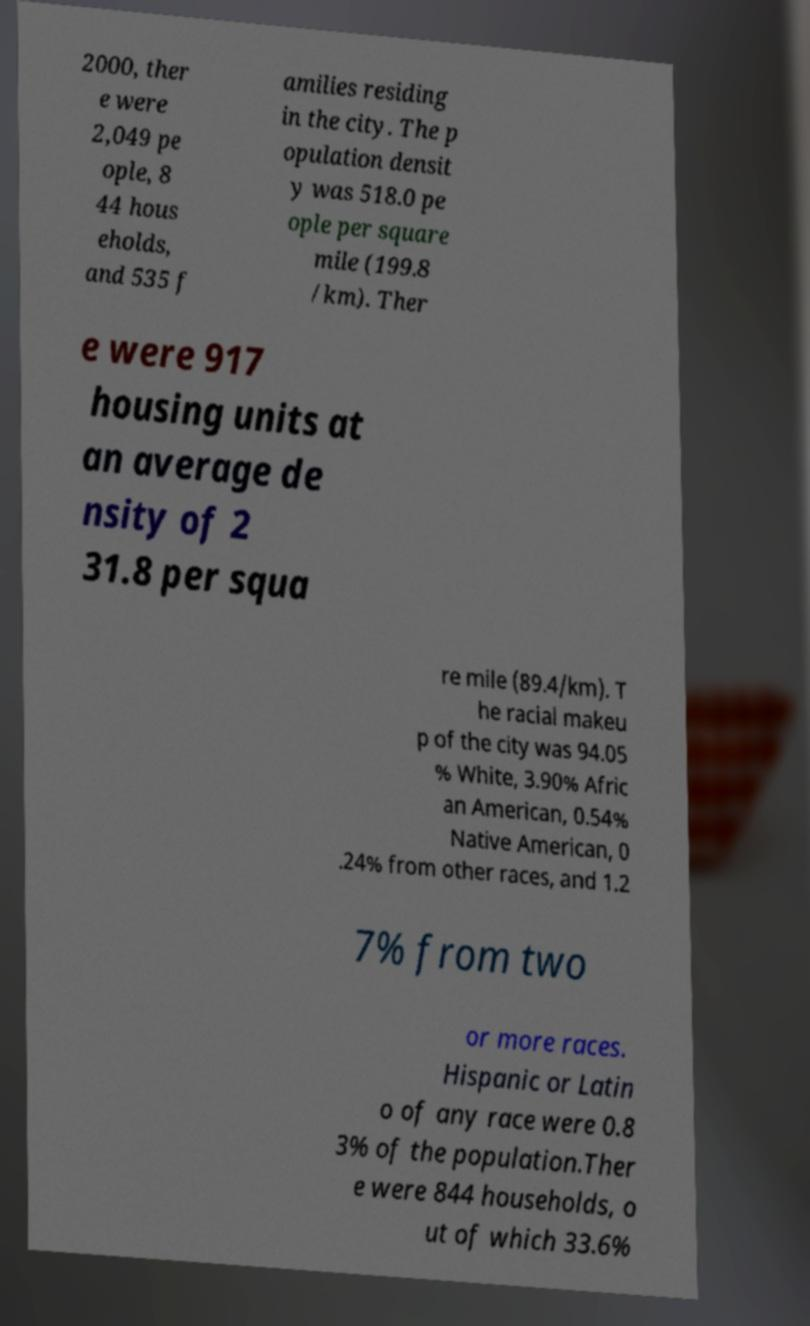What messages or text are displayed in this image? I need them in a readable, typed format. 2000, ther e were 2,049 pe ople, 8 44 hous eholds, and 535 f amilies residing in the city. The p opulation densit y was 518.0 pe ople per square mile (199.8 /km). Ther e were 917 housing units at an average de nsity of 2 31.8 per squa re mile (89.4/km). T he racial makeu p of the city was 94.05 % White, 3.90% Afric an American, 0.54% Native American, 0 .24% from other races, and 1.2 7% from two or more races. Hispanic or Latin o of any race were 0.8 3% of the population.Ther e were 844 households, o ut of which 33.6% 